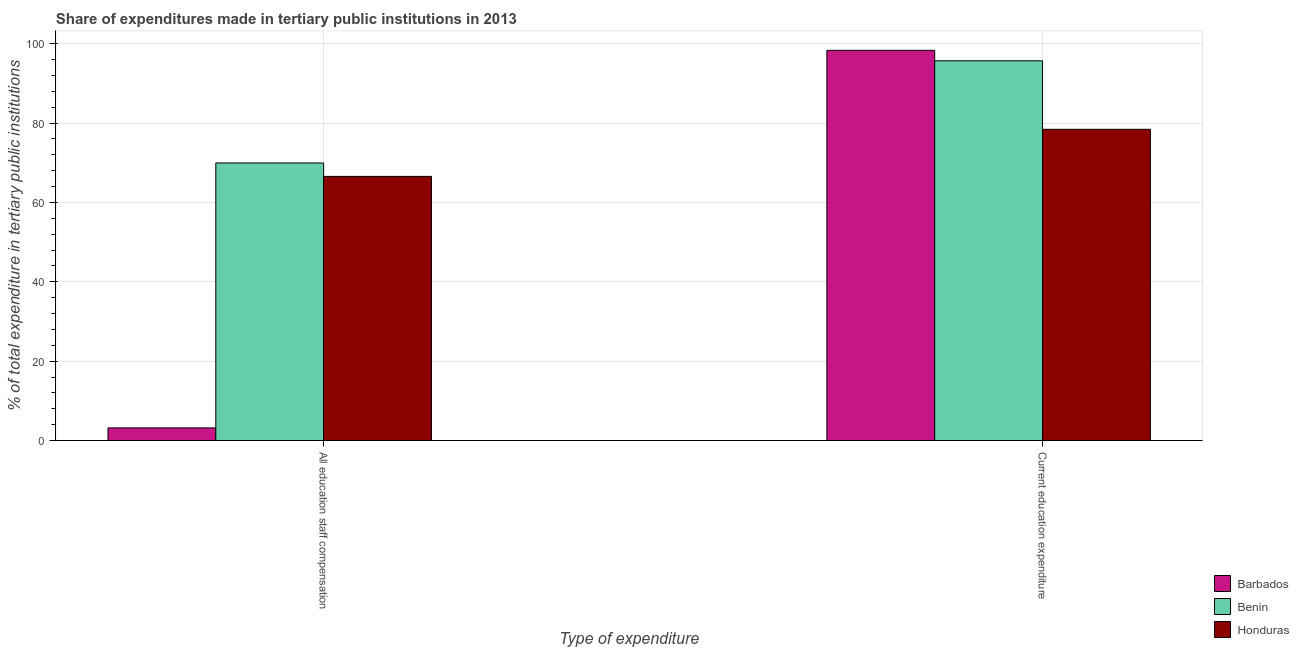How many different coloured bars are there?
Make the answer very short. 3. Are the number of bars on each tick of the X-axis equal?
Provide a short and direct response. Yes. What is the label of the 1st group of bars from the left?
Offer a terse response. All education staff compensation. What is the expenditure in staff compensation in Barbados?
Your answer should be very brief. 3.2. Across all countries, what is the maximum expenditure in education?
Keep it short and to the point. 98.34. Across all countries, what is the minimum expenditure in education?
Offer a very short reply. 78.43. In which country was the expenditure in education maximum?
Make the answer very short. Barbados. In which country was the expenditure in education minimum?
Give a very brief answer. Honduras. What is the total expenditure in education in the graph?
Make the answer very short. 272.47. What is the difference between the expenditure in education in Barbados and that in Honduras?
Provide a short and direct response. 19.9. What is the difference between the expenditure in education in Barbados and the expenditure in staff compensation in Benin?
Provide a short and direct response. 28.38. What is the average expenditure in staff compensation per country?
Your answer should be very brief. 46.57. What is the difference between the expenditure in education and expenditure in staff compensation in Benin?
Offer a very short reply. 25.74. In how many countries, is the expenditure in staff compensation greater than 80 %?
Offer a terse response. 0. What is the ratio of the expenditure in staff compensation in Benin to that in Honduras?
Offer a very short reply. 1.05. Is the expenditure in education in Benin less than that in Honduras?
Offer a very short reply. No. What does the 1st bar from the left in Current education expenditure represents?
Provide a succinct answer. Barbados. What does the 1st bar from the right in All education staff compensation represents?
Ensure brevity in your answer.  Honduras. Are all the bars in the graph horizontal?
Give a very brief answer. No. What is the difference between two consecutive major ticks on the Y-axis?
Offer a very short reply. 20. Does the graph contain grids?
Ensure brevity in your answer.  Yes. How are the legend labels stacked?
Ensure brevity in your answer.  Vertical. What is the title of the graph?
Give a very brief answer. Share of expenditures made in tertiary public institutions in 2013. Does "South Sudan" appear as one of the legend labels in the graph?
Keep it short and to the point. No. What is the label or title of the X-axis?
Make the answer very short. Type of expenditure. What is the label or title of the Y-axis?
Provide a succinct answer. % of total expenditure in tertiary public institutions. What is the % of total expenditure in tertiary public institutions in Barbados in All education staff compensation?
Ensure brevity in your answer.  3.2. What is the % of total expenditure in tertiary public institutions of Benin in All education staff compensation?
Keep it short and to the point. 69.96. What is the % of total expenditure in tertiary public institutions in Honduras in All education staff compensation?
Ensure brevity in your answer.  66.57. What is the % of total expenditure in tertiary public institutions of Barbados in Current education expenditure?
Provide a succinct answer. 98.34. What is the % of total expenditure in tertiary public institutions of Benin in Current education expenditure?
Provide a succinct answer. 95.7. What is the % of total expenditure in tertiary public institutions in Honduras in Current education expenditure?
Provide a short and direct response. 78.43. Across all Type of expenditure, what is the maximum % of total expenditure in tertiary public institutions in Barbados?
Keep it short and to the point. 98.34. Across all Type of expenditure, what is the maximum % of total expenditure in tertiary public institutions in Benin?
Offer a very short reply. 95.7. Across all Type of expenditure, what is the maximum % of total expenditure in tertiary public institutions of Honduras?
Ensure brevity in your answer.  78.43. Across all Type of expenditure, what is the minimum % of total expenditure in tertiary public institutions of Barbados?
Offer a very short reply. 3.2. Across all Type of expenditure, what is the minimum % of total expenditure in tertiary public institutions of Benin?
Offer a terse response. 69.96. Across all Type of expenditure, what is the minimum % of total expenditure in tertiary public institutions in Honduras?
Make the answer very short. 66.57. What is the total % of total expenditure in tertiary public institutions in Barbados in the graph?
Your response must be concise. 101.53. What is the total % of total expenditure in tertiary public institutions of Benin in the graph?
Offer a very short reply. 165.65. What is the total % of total expenditure in tertiary public institutions of Honduras in the graph?
Offer a very short reply. 145. What is the difference between the % of total expenditure in tertiary public institutions in Barbados in All education staff compensation and that in Current education expenditure?
Ensure brevity in your answer.  -95.14. What is the difference between the % of total expenditure in tertiary public institutions of Benin in All education staff compensation and that in Current education expenditure?
Offer a very short reply. -25.74. What is the difference between the % of total expenditure in tertiary public institutions of Honduras in All education staff compensation and that in Current education expenditure?
Provide a short and direct response. -11.86. What is the difference between the % of total expenditure in tertiary public institutions in Barbados in All education staff compensation and the % of total expenditure in tertiary public institutions in Benin in Current education expenditure?
Ensure brevity in your answer.  -92.5. What is the difference between the % of total expenditure in tertiary public institutions of Barbados in All education staff compensation and the % of total expenditure in tertiary public institutions of Honduras in Current education expenditure?
Make the answer very short. -75.24. What is the difference between the % of total expenditure in tertiary public institutions of Benin in All education staff compensation and the % of total expenditure in tertiary public institutions of Honduras in Current education expenditure?
Your response must be concise. -8.48. What is the average % of total expenditure in tertiary public institutions in Barbados per Type of expenditure?
Give a very brief answer. 50.77. What is the average % of total expenditure in tertiary public institutions in Benin per Type of expenditure?
Ensure brevity in your answer.  82.83. What is the average % of total expenditure in tertiary public institutions of Honduras per Type of expenditure?
Offer a very short reply. 72.5. What is the difference between the % of total expenditure in tertiary public institutions of Barbados and % of total expenditure in tertiary public institutions of Benin in All education staff compensation?
Ensure brevity in your answer.  -66.76. What is the difference between the % of total expenditure in tertiary public institutions in Barbados and % of total expenditure in tertiary public institutions in Honduras in All education staff compensation?
Provide a short and direct response. -63.38. What is the difference between the % of total expenditure in tertiary public institutions in Benin and % of total expenditure in tertiary public institutions in Honduras in All education staff compensation?
Keep it short and to the point. 3.38. What is the difference between the % of total expenditure in tertiary public institutions of Barbados and % of total expenditure in tertiary public institutions of Benin in Current education expenditure?
Your answer should be compact. 2.64. What is the difference between the % of total expenditure in tertiary public institutions of Barbados and % of total expenditure in tertiary public institutions of Honduras in Current education expenditure?
Offer a very short reply. 19.9. What is the difference between the % of total expenditure in tertiary public institutions in Benin and % of total expenditure in tertiary public institutions in Honduras in Current education expenditure?
Make the answer very short. 17.26. What is the ratio of the % of total expenditure in tertiary public institutions of Barbados in All education staff compensation to that in Current education expenditure?
Offer a very short reply. 0.03. What is the ratio of the % of total expenditure in tertiary public institutions in Benin in All education staff compensation to that in Current education expenditure?
Make the answer very short. 0.73. What is the ratio of the % of total expenditure in tertiary public institutions of Honduras in All education staff compensation to that in Current education expenditure?
Provide a succinct answer. 0.85. What is the difference between the highest and the second highest % of total expenditure in tertiary public institutions in Barbados?
Ensure brevity in your answer.  95.14. What is the difference between the highest and the second highest % of total expenditure in tertiary public institutions of Benin?
Give a very brief answer. 25.74. What is the difference between the highest and the second highest % of total expenditure in tertiary public institutions in Honduras?
Your answer should be compact. 11.86. What is the difference between the highest and the lowest % of total expenditure in tertiary public institutions of Barbados?
Your answer should be compact. 95.14. What is the difference between the highest and the lowest % of total expenditure in tertiary public institutions in Benin?
Give a very brief answer. 25.74. What is the difference between the highest and the lowest % of total expenditure in tertiary public institutions in Honduras?
Your answer should be very brief. 11.86. 